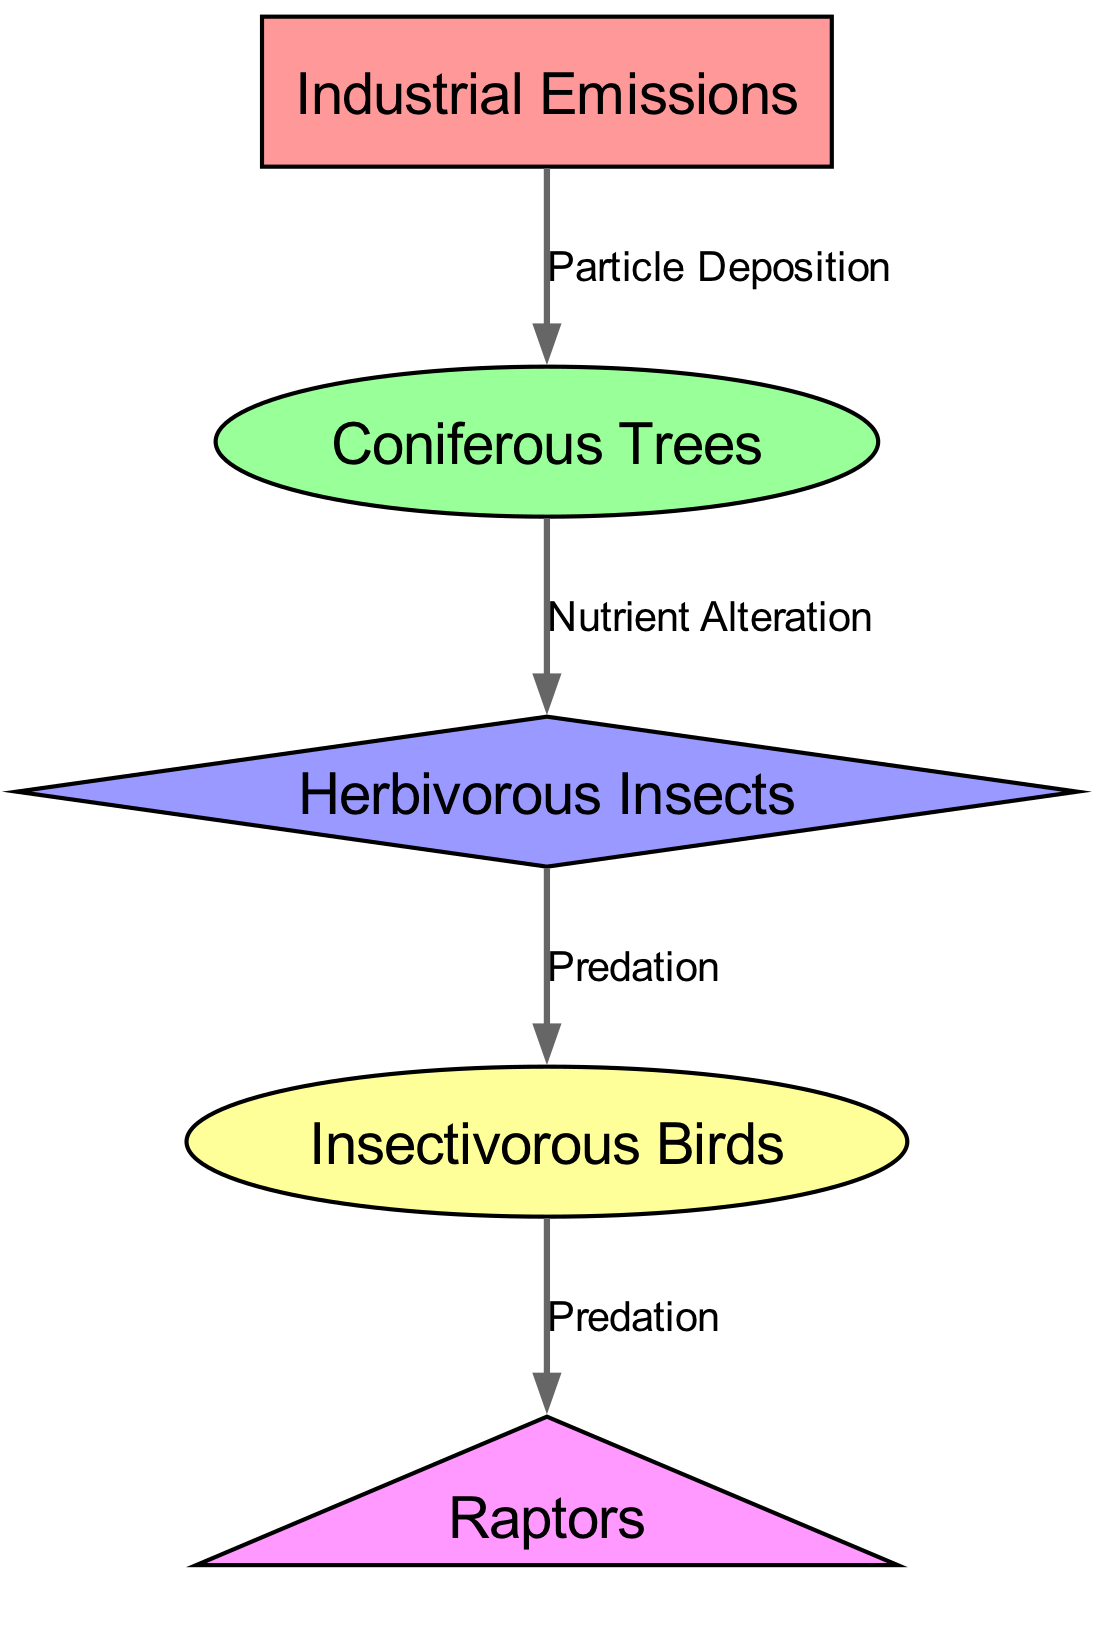What is the first node in the diagram? The nodes are displayed in order from the top down, beginning with "Industrial Emissions" at the top.
Answer: Industrial Emissions How many nodes are present in the diagram? Counting all the nodes listed: "Industrial Emissions", "Coniferous Trees", "Herbivorous Insects", "Insectivorous Birds", and "Raptors" gives a total of five nodes.
Answer: 5 What relationship is shown between "Industrial Emissions" and "Coniferous Trees"? The edge connecting "Industrial Emissions" to "Coniferous Trees" is labeled "Particle Deposition", indicating the influence of emissions on tree health.
Answer: Particle Deposition Which node is the prey of "Insectivorous Birds"? The node directly connected to "Insectivorous Birds" via a predation edge is "Herbivorous Insects", indicating this is the food source for the birds.
Answer: Herbivorous Insects What type of relationship exists between "Coniferous Trees" and "Herbivorous Insects"? The connection is labeled "Nutrient Alteration", indicating that the trees have a role in changing nutrient availability for the insects, which they depend on for survival.
Answer: Nutrient Alteration How many edges are in the diagram? By counting the connections provided: from "Industrial Emissions" to "Coniferous Trees", from "Coniferous Trees" to "Herbivorous Insects", from "Herbivorous Insects" to "Insectivorous Birds", and from "Insectivorous Birds" to "Raptors", there are four edges in total.
Answer: 4 What is the final node in this food chain? The last node depicted at the bottom of the diagram is "Raptors", which concludes the food chain.
Answer: Raptors Which node serves as a producer in this diagram? The "Coniferous Trees" node is typically recognized as a producer, providing energy and nutrients within this ecosystem.
Answer: Coniferous Trees How many predator relationships are represented in the diagram? Analyzing the edges reveals that there are two predator relationships: between "Herbivorous Insects" and "Insectivorous Birds", and between "Insectivorous Birds" and "Raptors".
Answer: 2 